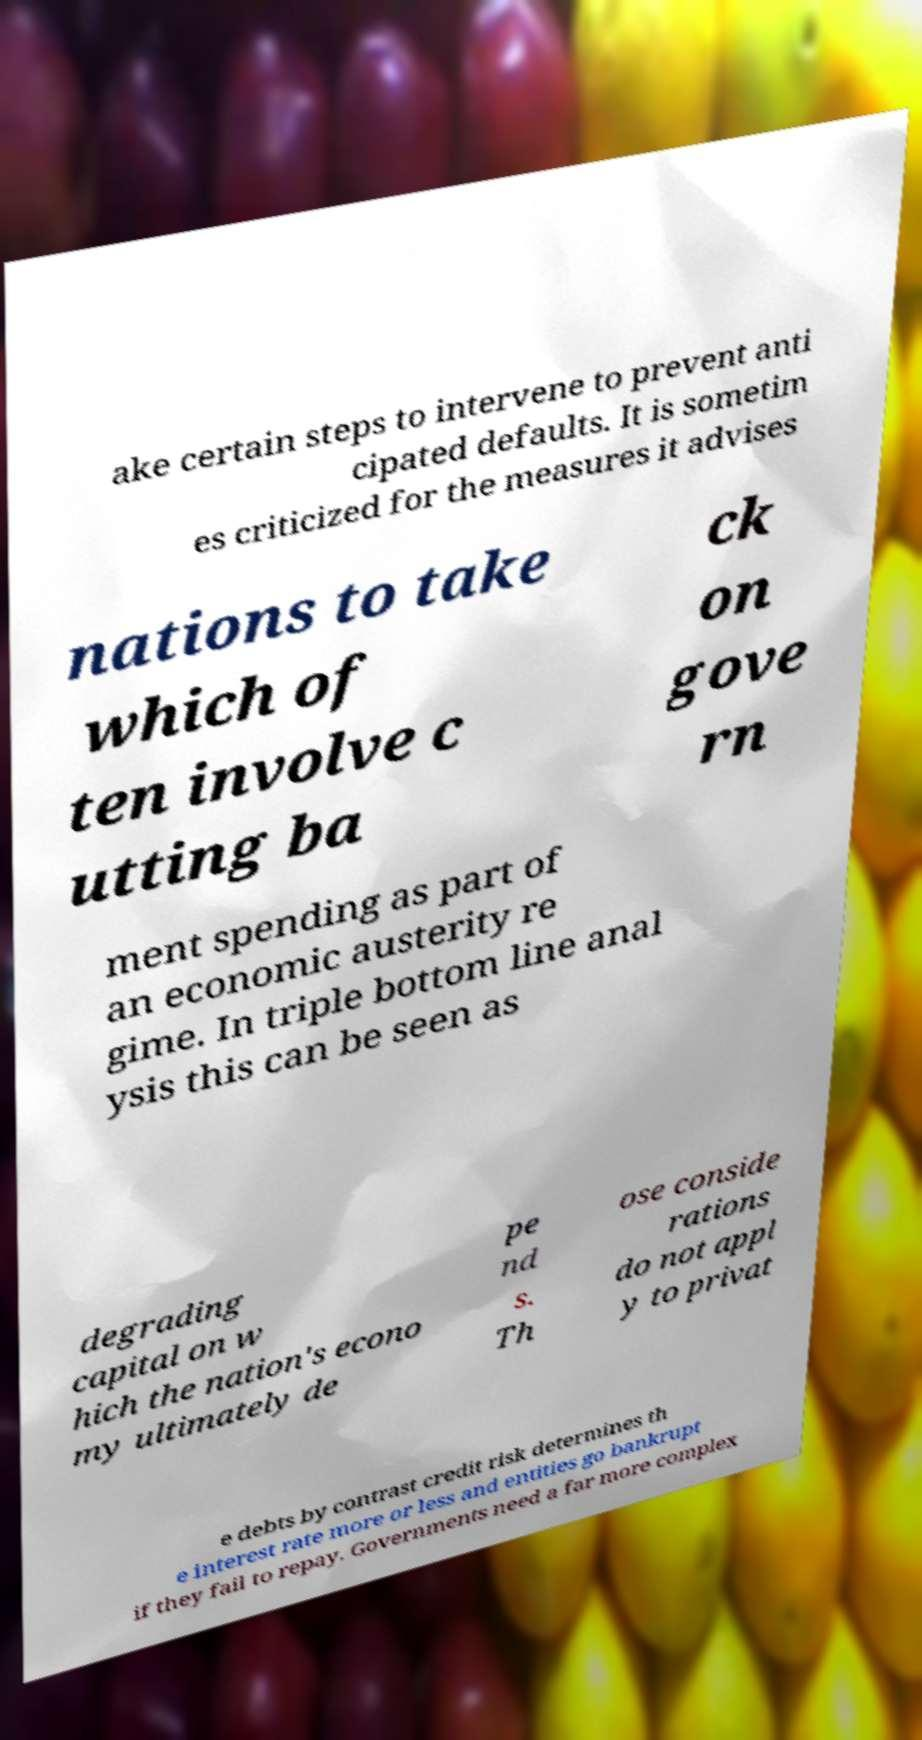For documentation purposes, I need the text within this image transcribed. Could you provide that? ake certain steps to intervene to prevent anti cipated defaults. It is sometim es criticized for the measures it advises nations to take which of ten involve c utting ba ck on gove rn ment spending as part of an economic austerity re gime. In triple bottom line anal ysis this can be seen as degrading capital on w hich the nation's econo my ultimately de pe nd s. Th ose conside rations do not appl y to privat e debts by contrast credit risk determines th e interest rate more or less and entities go bankrupt if they fail to repay. Governments need a far more complex 